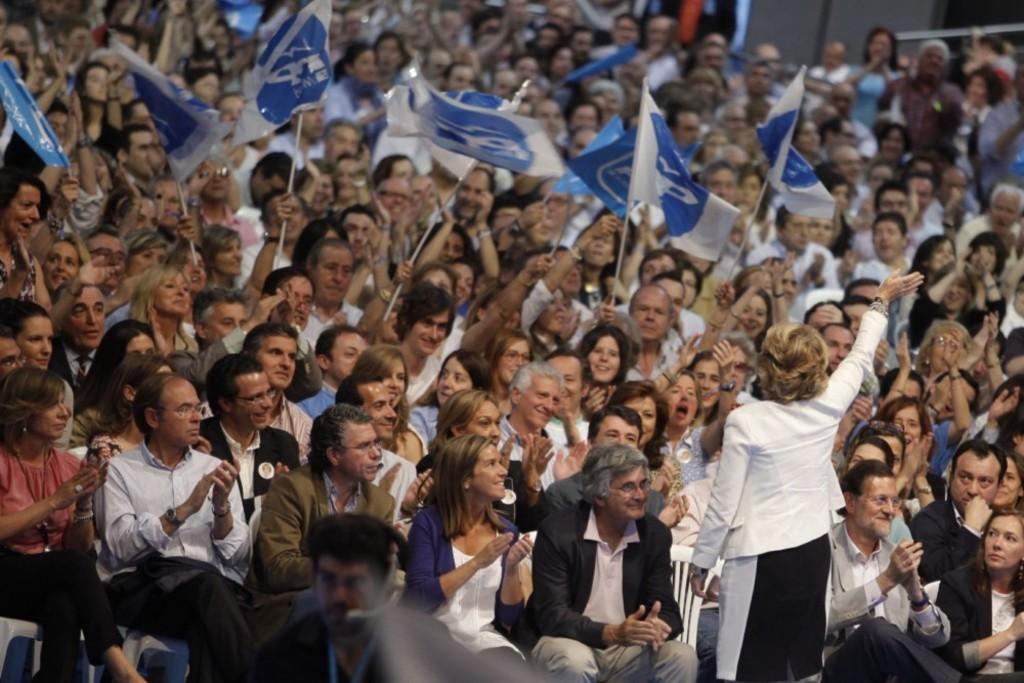What is the main subject of the image? The main subject of the image is a group of people. What are some of the people in the image holding? Some of the people in the image are holding flags in their hands. What type of bubble can be seen floating near the group of people in the image? There is no bubble present in the image. 